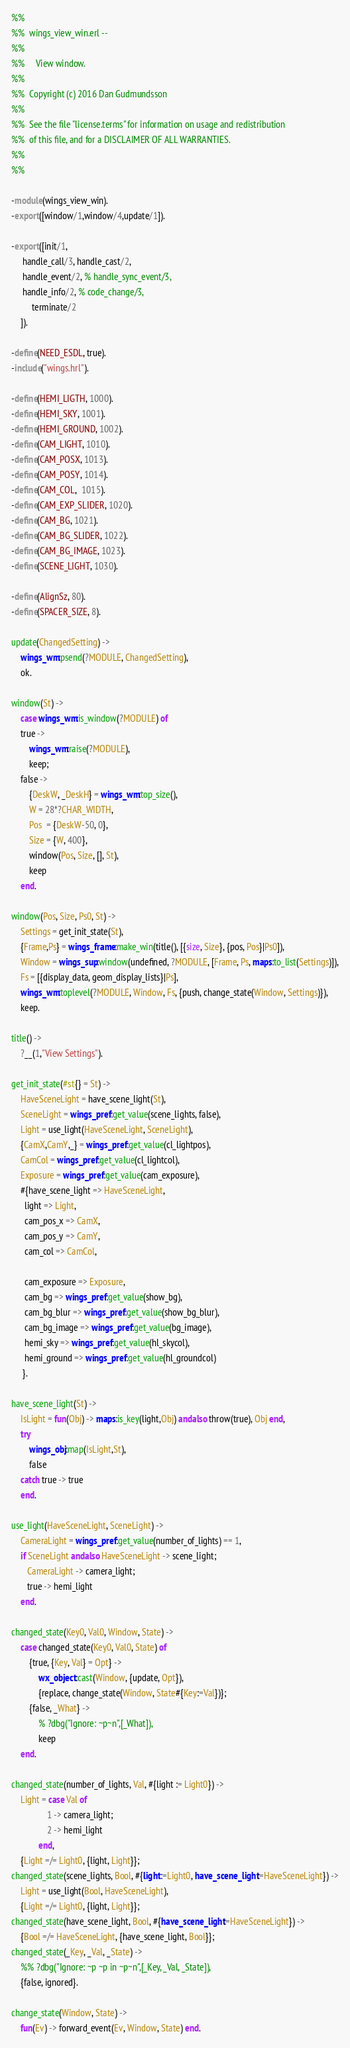Convert code to text. <code><loc_0><loc_0><loc_500><loc_500><_Erlang_>%%
%%  wings_view_win.erl --
%%
%%     View window.
%%
%%  Copyright (c) 2016 Dan Gudmundsson
%%
%%  See the file "license.terms" for information on usage and redistribution
%%  of this file, and for a DISCLAIMER OF ALL WARRANTIES.
%%
%%

-module(wings_view_win).
-export([window/1,window/4,update/1]).

-export([init/1,
	 handle_call/3, handle_cast/2,
	 handle_event/2, % handle_sync_event/3,
	 handle_info/2, % code_change/3,
         terminate/2
	]).

-define(NEED_ESDL, true).
-include("wings.hrl").

-define(HEMI_LIGTH, 1000).
-define(HEMI_SKY, 1001).
-define(HEMI_GROUND, 1002).
-define(CAM_LIGHT, 1010).
-define(CAM_POSX, 1013).
-define(CAM_POSY, 1014).
-define(CAM_COL,  1015).
-define(CAM_EXP_SLIDER, 1020).
-define(CAM_BG, 1021).
-define(CAM_BG_SLIDER, 1022).
-define(CAM_BG_IMAGE, 1023).
-define(SCENE_LIGHT, 1030).

-define(AlignSz, 80).
-define(SPACER_SIZE, 8).

update(ChangedSetting) ->
    wings_wm:psend(?MODULE, ChangedSetting),
    ok.

window(St) ->
    case wings_wm:is_window(?MODULE) of
	true ->
	    wings_wm:raise(?MODULE),
	    keep;
	false ->
	    {DeskW, _DeskH} = wings_wm:top_size(),
	    W = 28*?CHAR_WIDTH,
	    Pos  = {DeskW-50, 0},
	    Size = {W, 400},
	    window(Pos, Size, [], St),
	    keep
    end.

window(Pos, Size, Ps0, St) ->
    Settings = get_init_state(St),
    {Frame,Ps} = wings_frame:make_win(title(), [{size, Size}, {pos, Pos}|Ps0]),
    Window = wings_sup:window(undefined, ?MODULE, [Frame, Ps, maps:to_list(Settings)]),
    Fs = [{display_data, geom_display_lists}|Ps],
    wings_wm:toplevel(?MODULE, Window, Fs, {push, change_state(Window, Settings)}),
    keep.

title() ->
    ?__(1,"View Settings").

get_init_state(#st{} = St) ->
    HaveSceneLight = have_scene_light(St),
    SceneLight = wings_pref:get_value(scene_lights, false),
    Light = use_light(HaveSceneLight, SceneLight),
    {CamX,CamY,_} = wings_pref:get_value(cl_lightpos),
    CamCol = wings_pref:get_value(cl_lightcol),
    Exposure = wings_pref:get_value(cam_exposure),
    #{have_scene_light => HaveSceneLight,
      light => Light,
      cam_pos_x => CamX,
      cam_pos_y => CamY,
      cam_col => CamCol,

      cam_exposure => Exposure,
      cam_bg => wings_pref:get_value(show_bg),
      cam_bg_blur => wings_pref:get_value(show_bg_blur),
      cam_bg_image => wings_pref:get_value(bg_image),
      hemi_sky => wings_pref:get_value(hl_skycol),
      hemi_ground => wings_pref:get_value(hl_groundcol)
     }.

have_scene_light(St) ->
    IsLight = fun(Obj) -> maps:is_key(light,Obj) andalso throw(true), Obj end,
    try
        wings_obj:map(IsLight,St),
        false
    catch true -> true
    end.

use_light(HaveSceneLight, SceneLight) ->
    CameraLight = wings_pref:get_value(number_of_lights) == 1,
    if SceneLight andalso HaveSceneLight -> scene_light;
       CameraLight -> camera_light;
       true -> hemi_light
    end.

changed_state(Key0, Val0, Window, State) ->
    case changed_state(Key0, Val0, State) of
        {true, {Key, Val} = Opt} ->
            wx_object:cast(Window, {update, Opt}),
            {replace, change_state(Window, State#{Key:=Val})};
        {false, _What} ->
            % ?dbg("Ignore: ~p~n",[_What]),
            keep
    end.

changed_state(number_of_lights, Val, #{light := Light0}) ->
    Light = case Val of
                1 -> camera_light;
                2 -> hemi_light
            end,
    {Light =/= Light0, {light, Light}};
changed_state(scene_lights, Bool, #{light:=Light0, have_scene_light:=HaveSceneLight}) ->
    Light = use_light(Bool, HaveSceneLight),
    {Light =/= Light0, {light, Light}};
changed_state(have_scene_light, Bool, #{have_scene_light:=HaveSceneLight}) ->
    {Bool =/= HaveSceneLight, {have_scene_light, Bool}};
changed_state(_Key, _Val, _State) ->
    %% ?dbg("Ignore: ~p ~p in ~p~n",[_Key, _Val, _State]),
    {false, ignored}.

change_state(Window, State) ->
    fun(Ev) -> forward_event(Ev, Window, State) end.
</code> 